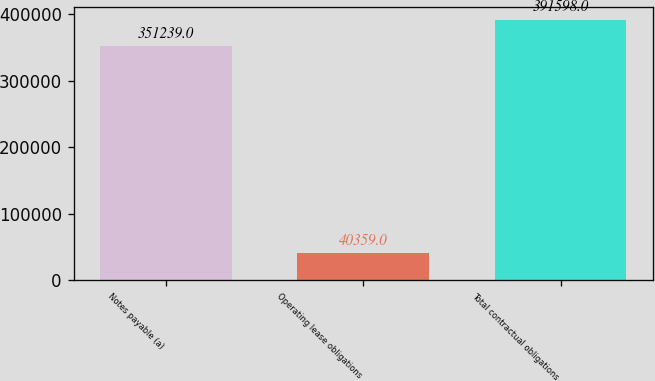Convert chart. <chart><loc_0><loc_0><loc_500><loc_500><bar_chart><fcel>Notes payable (a)<fcel>Operating lease obligations<fcel>Total contractual obligations<nl><fcel>351239<fcel>40359<fcel>391598<nl></chart> 